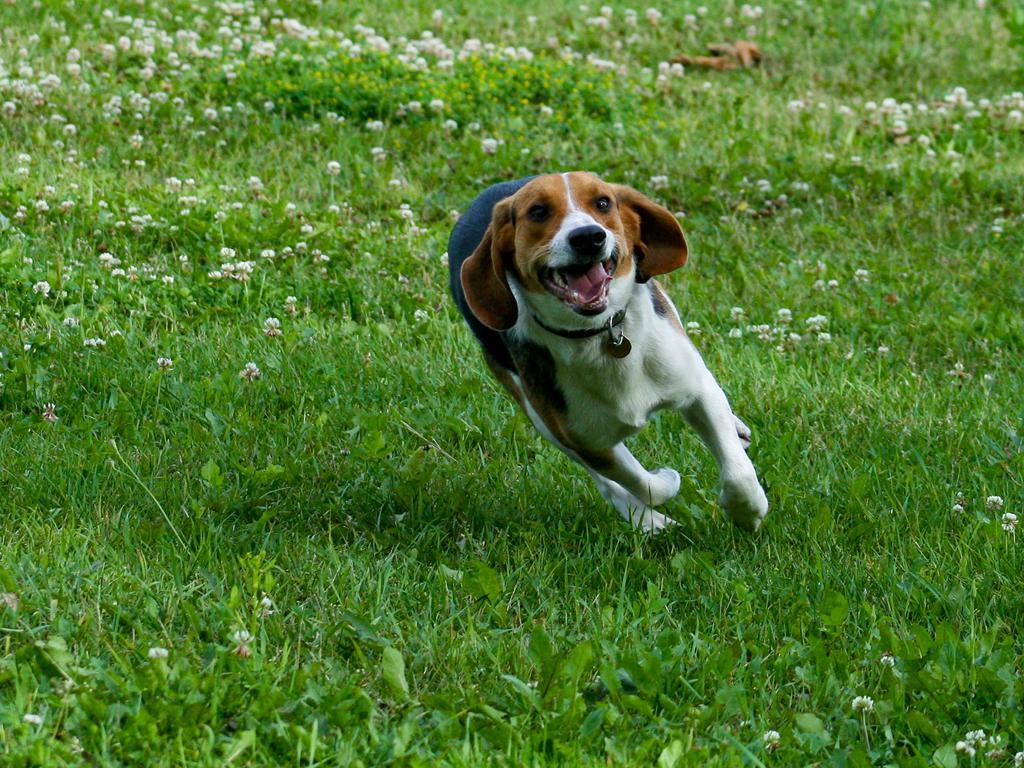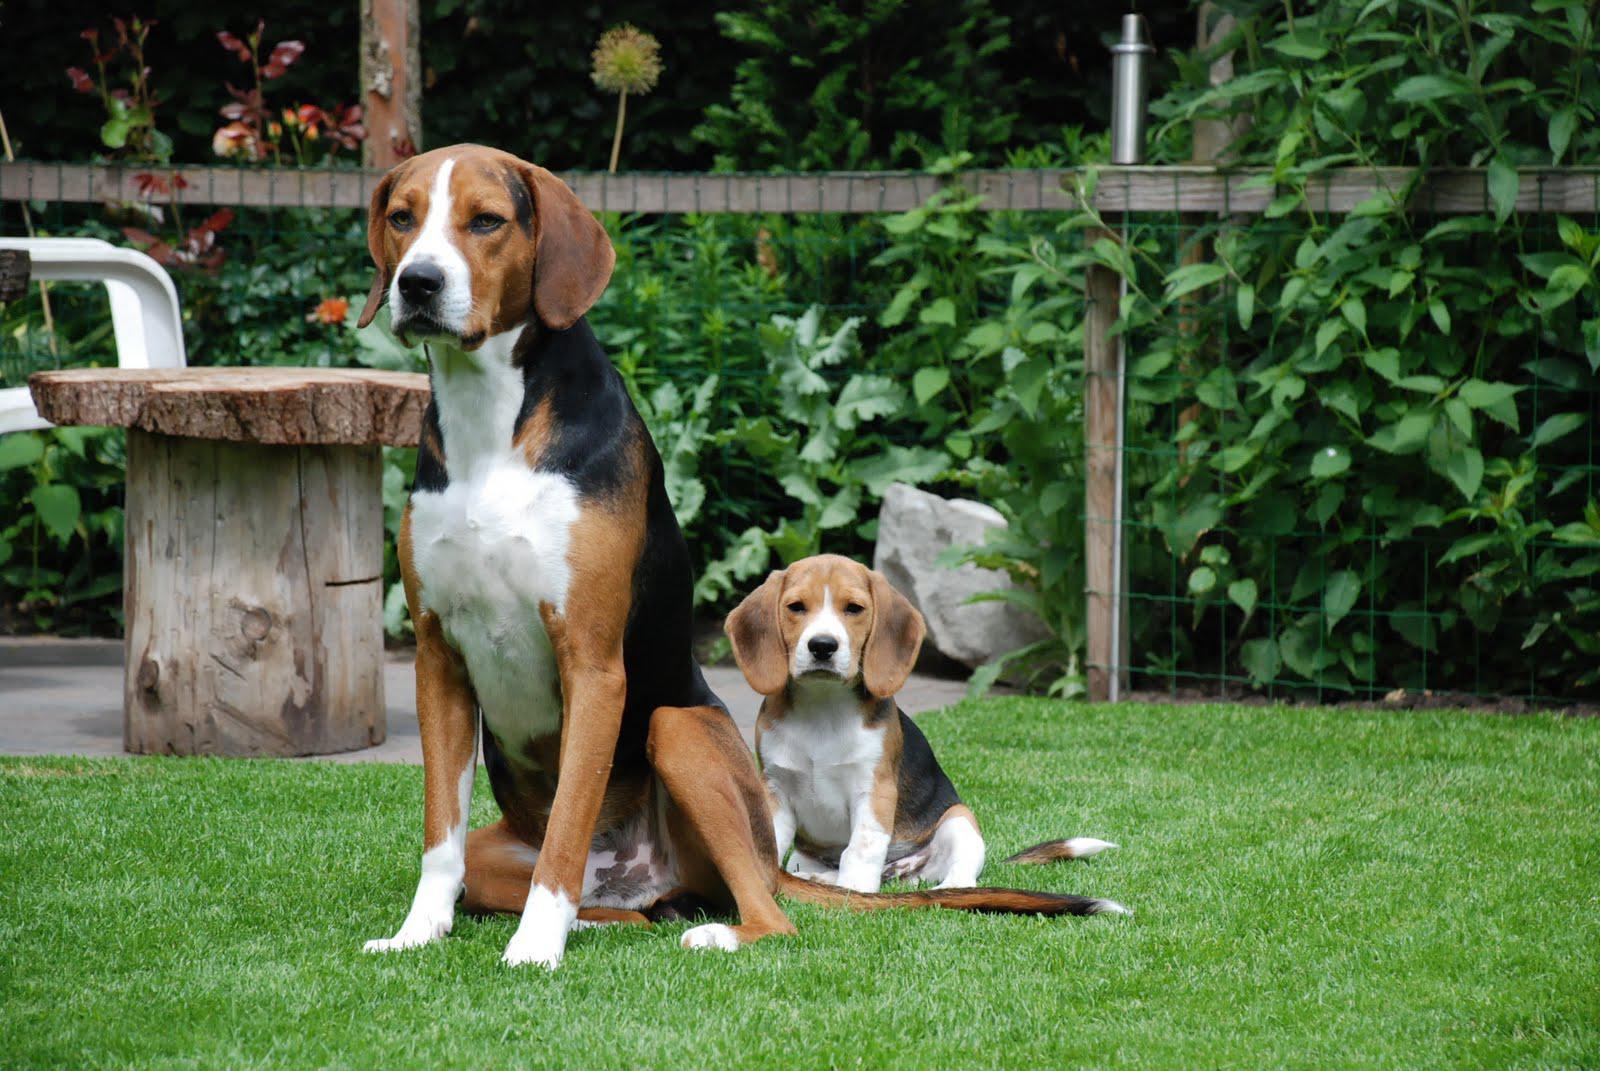The first image is the image on the left, the second image is the image on the right. For the images shown, is this caption "Four dogs are in the grass, and one has a red ball in its mouth." true? Answer yes or no. No. The first image is the image on the left, the second image is the image on the right. For the images shown, is this caption "There are more than one beagle in the image on the right" true? Answer yes or no. Yes. 